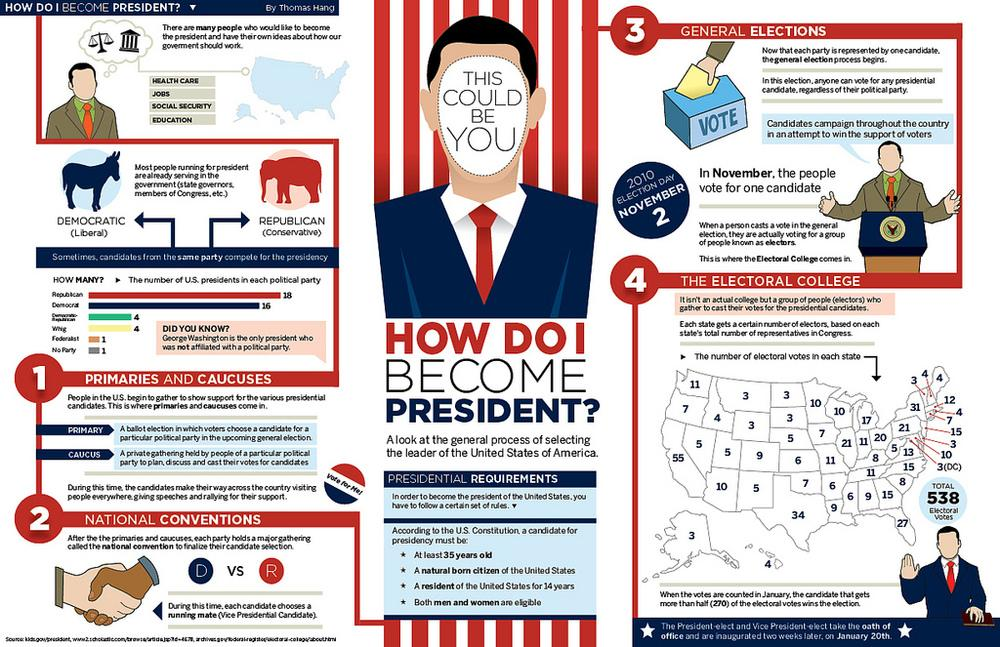Give some essential details in this illustration. George Washington was the only U.S. president who was not affiliated with a political party. The Democratic and Republican parties are the two dominant political parties in the United States. The Republican Party in the United States has had the most number of Presidents. U.S. constitution mandates that a presidential candidate must have at least 14 years of U.S. residency. According to the U.S. Constitution, a candidate for presidency must be at least 35 years old. 